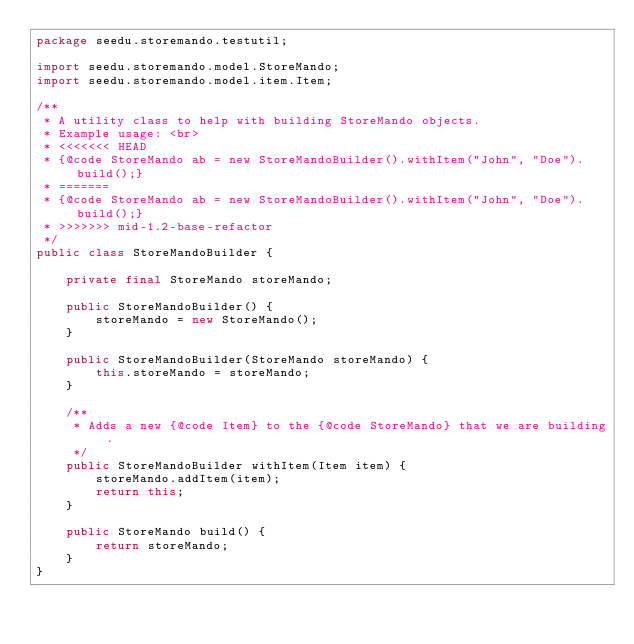Convert code to text. <code><loc_0><loc_0><loc_500><loc_500><_Java_>package seedu.storemando.testutil;

import seedu.storemando.model.StoreMando;
import seedu.storemando.model.item.Item;

/**
 * A utility class to help with building StoreMando objects.
 * Example usage: <br>
 * <<<<<<< HEAD
 * {@code StoreMando ab = new StoreMandoBuilder().withItem("John", "Doe").build();}
 * =======
 * {@code StoreMando ab = new StoreMandoBuilder().withItem("John", "Doe").build();}
 * >>>>>>> mid-1.2-base-refactor
 */
public class StoreMandoBuilder {

    private final StoreMando storeMando;

    public StoreMandoBuilder() {
        storeMando = new StoreMando();
    }

    public StoreMandoBuilder(StoreMando storeMando) {
        this.storeMando = storeMando;
    }

    /**
     * Adds a new {@code Item} to the {@code StoreMando} that we are building.
     */
    public StoreMandoBuilder withItem(Item item) {
        storeMando.addItem(item);
        return this;
    }

    public StoreMando build() {
        return storeMando;
    }
}
</code> 